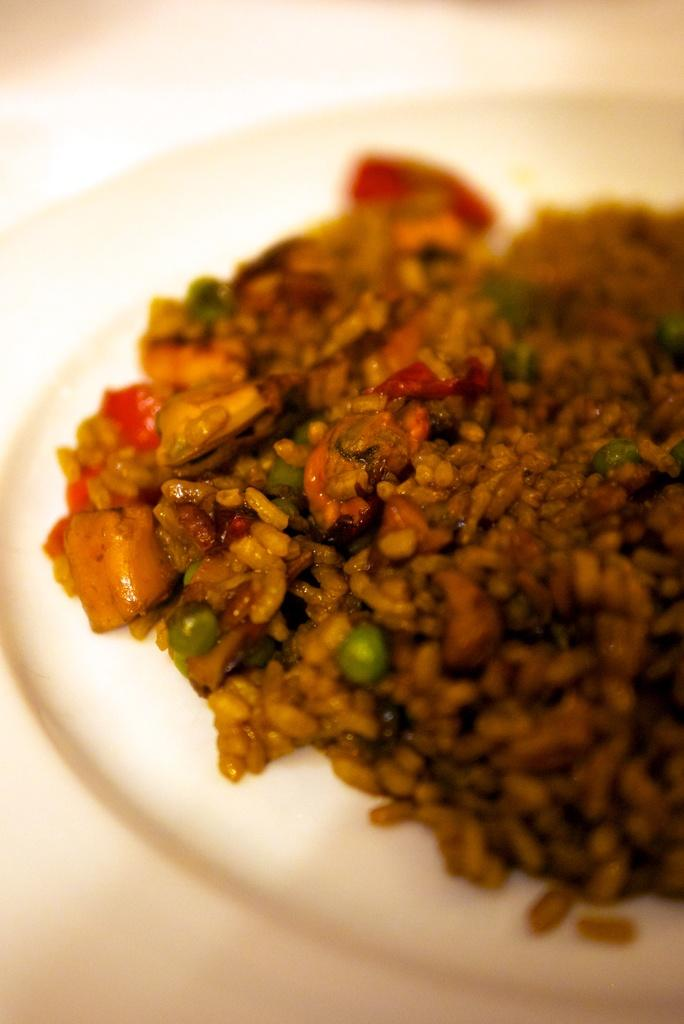What type of plate is visible in the image? There is a white plate in the image. What color is the food on the plate? The food on the plate is brown-colored. Can you describe the clarity of the image? The image may be slightly blurry in the background. What type of balls are being juggled by the judge in the image? There is no judge or balls present in the image. 